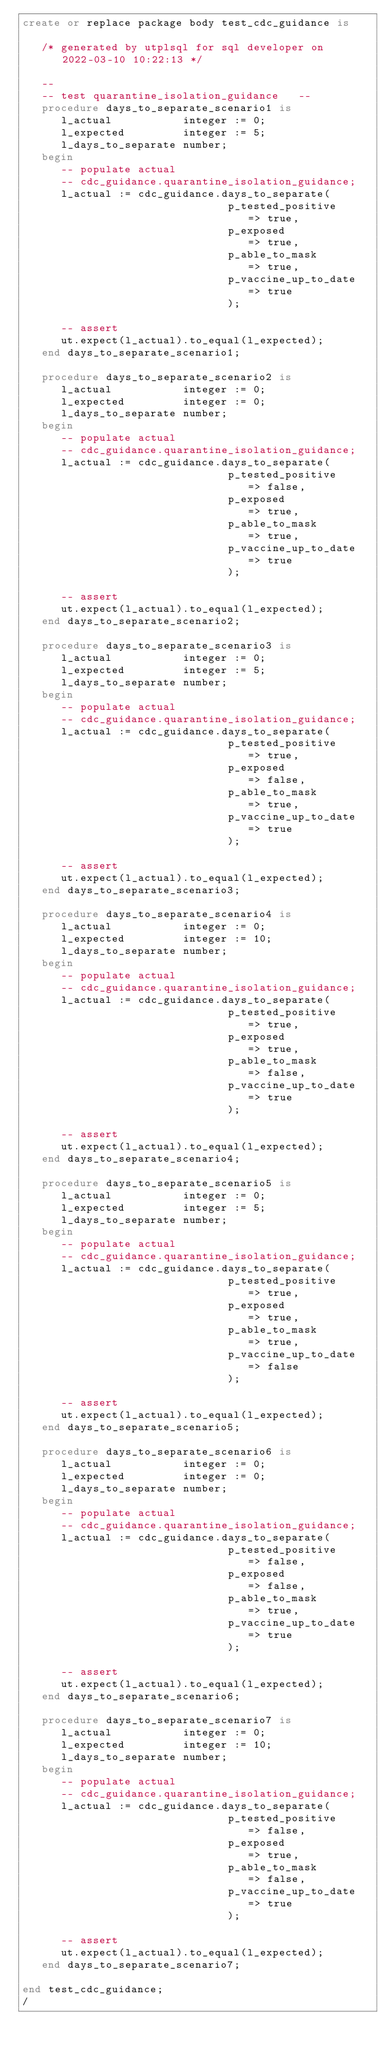Convert code to text. <code><loc_0><loc_0><loc_500><loc_500><_SQL_>create or replace package body test_cdc_guidance is

   /* generated by utplsql for sql developer on 2022-03-10 10:22:13 */

   --
   -- test quarantine_isolation_guidance   --
   procedure days_to_separate_scenario1 is
      l_actual           integer := 0;
      l_expected         integer := 5;
      l_days_to_separate number;
   begin
      -- populate actual
      -- cdc_guidance.quarantine_isolation_guidance;
      l_actual := cdc_guidance.days_to_separate(
                                p_tested_positive    => true, 
                                p_exposed            => true,
                                p_able_to_mask       => true,
                                p_vaccine_up_to_date => true
                                );

      -- assert
      ut.expect(l_actual).to_equal(l_expected);
   end days_to_separate_scenario1;
   
   procedure days_to_separate_scenario2 is
      l_actual           integer := 0;
      l_expected         integer := 0;
      l_days_to_separate number;
   begin
      -- populate actual
      -- cdc_guidance.quarantine_isolation_guidance;
      l_actual := cdc_guidance.days_to_separate(
                                p_tested_positive    => false, 
                                p_exposed            => true,
                                p_able_to_mask       => true,
                                p_vaccine_up_to_date => true
                                );

      -- assert
      ut.expect(l_actual).to_equal(l_expected);
   end days_to_separate_scenario2;
   
   procedure days_to_separate_scenario3 is
      l_actual           integer := 0;
      l_expected         integer := 5;
      l_days_to_separate number;
   begin
      -- populate actual
      -- cdc_guidance.quarantine_isolation_guidance;
      l_actual := cdc_guidance.days_to_separate(
                                p_tested_positive    => true, 
                                p_exposed            => false,
                                p_able_to_mask       => true,
                                p_vaccine_up_to_date => true
                                );

      -- assert
      ut.expect(l_actual).to_equal(l_expected);
   end days_to_separate_scenario3;
   
   procedure days_to_separate_scenario4 is
      l_actual           integer := 0;
      l_expected         integer := 10;
      l_days_to_separate number;
   begin
      -- populate actual
      -- cdc_guidance.quarantine_isolation_guidance;
      l_actual := cdc_guidance.days_to_separate(
                                p_tested_positive    => true, 
                                p_exposed            => true,
                                p_able_to_mask       => false,
                                p_vaccine_up_to_date => true
                                );

      -- assert
      ut.expect(l_actual).to_equal(l_expected);
   end days_to_separate_scenario4;
   
   procedure days_to_separate_scenario5 is
      l_actual           integer := 0;
      l_expected         integer := 5;
      l_days_to_separate number;
   begin
      -- populate actual
      -- cdc_guidance.quarantine_isolation_guidance;
      l_actual := cdc_guidance.days_to_separate(
                                p_tested_positive    => true, 
                                p_exposed            => true,
                                p_able_to_mask       => true,
                                p_vaccine_up_to_date => false
                                );

      -- assert
      ut.expect(l_actual).to_equal(l_expected);
   end days_to_separate_scenario5;
   
   procedure days_to_separate_scenario6 is
      l_actual           integer := 0;
      l_expected         integer := 0;
      l_days_to_separate number;
   begin
      -- populate actual
      -- cdc_guidance.quarantine_isolation_guidance;
      l_actual := cdc_guidance.days_to_separate(
                                p_tested_positive    => false, 
                                p_exposed            => false,
                                p_able_to_mask       => true,
                                p_vaccine_up_to_date => true
                                );

      -- assert
      ut.expect(l_actual).to_equal(l_expected);
   end days_to_separate_scenario6;
   
   procedure days_to_separate_scenario7 is
      l_actual           integer := 0;
      l_expected         integer := 10;
      l_days_to_separate number;
   begin
      -- populate actual
      -- cdc_guidance.quarantine_isolation_guidance;
      l_actual := cdc_guidance.days_to_separate(
                                p_tested_positive    => false, 
                                p_exposed            => true,
                                p_able_to_mask       => false,
                                p_vaccine_up_to_date => true
                                );

      -- assert
      ut.expect(l_actual).to_equal(l_expected);
   end days_to_separate_scenario7;

end test_cdc_guidance;
/</code> 